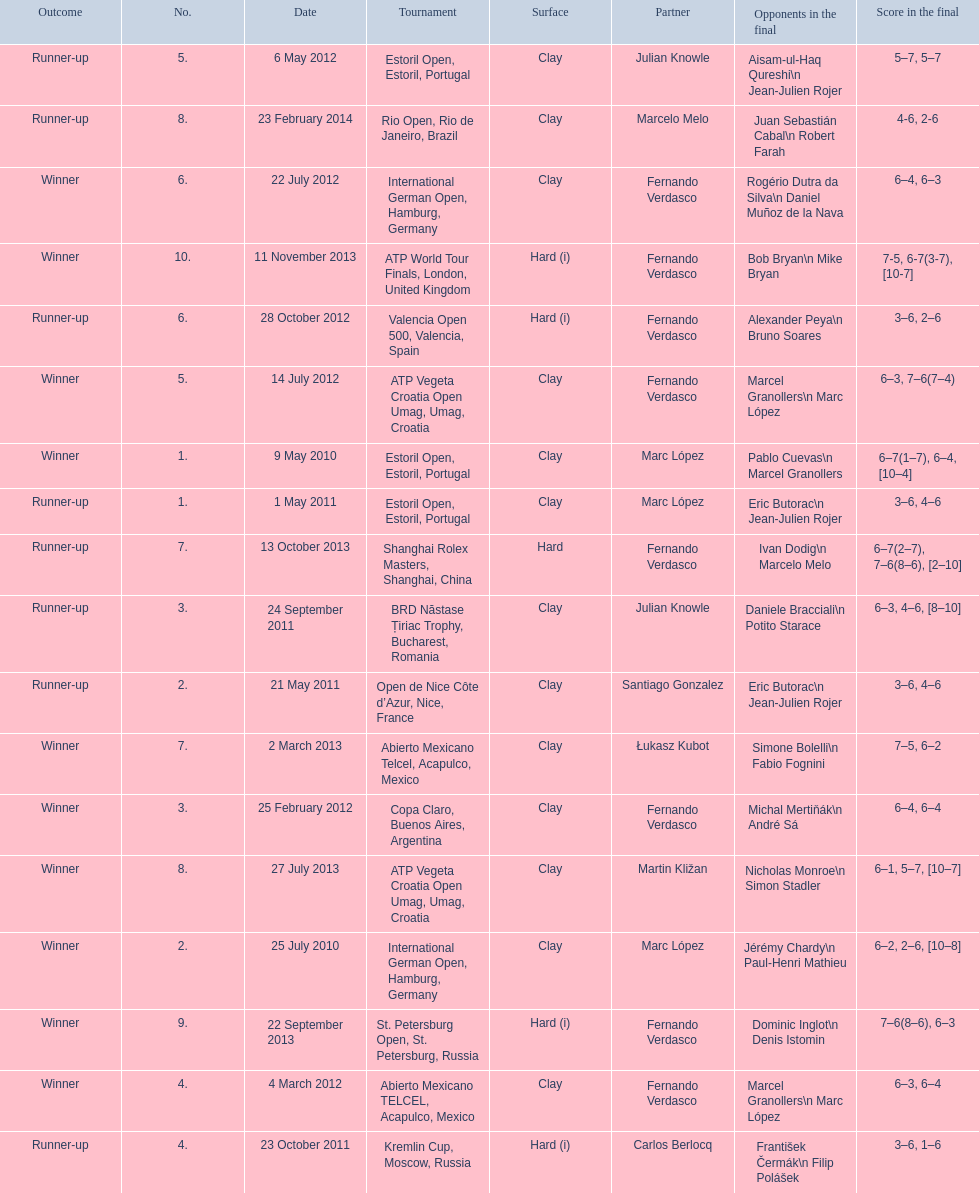How many winners are there? 10. 